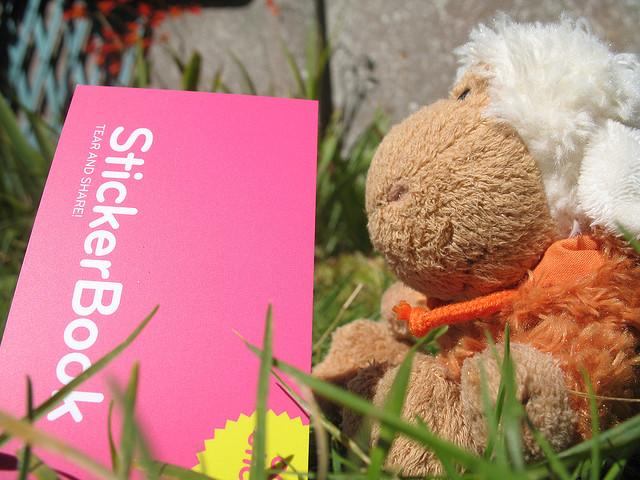Is the stuffed animal reading the book?
Give a very brief answer. No. What is pink in the image?
Keep it brief. Sticker book. What holiday are these gifts for?
Concise answer only. Easter. What is the name of the book?
Concise answer only. Sticker book. Is there a stuffed animal in the image?
Short answer required. Yes. What position is the bear in?
Keep it brief. Sitting. What is the bear holding?
Short answer required. Sticker book. Is there any animal in this picture?
Be succinct. No. 